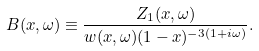<formula> <loc_0><loc_0><loc_500><loc_500>B ( x , \omega ) \equiv \frac { Z _ { 1 } ( x , \omega ) } { w ( x , \omega ) ( 1 - x ) ^ { - 3 ( 1 + i \omega ) } } .</formula> 